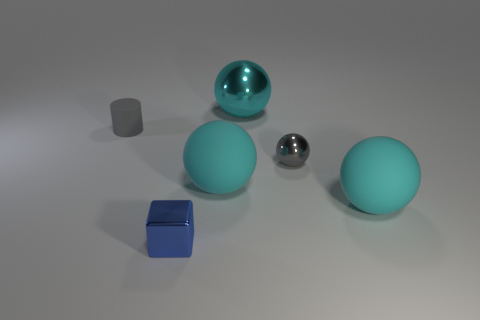What number of yellow objects are either cylinders or big metallic balls?
Ensure brevity in your answer.  0. There is a small gray object that is on the left side of the blue thing; what is it made of?
Offer a very short reply. Rubber. Are there more small matte things than small gray objects?
Provide a succinct answer. No. Does the shiny thing that is right of the cyan metal sphere have the same shape as the large metal thing?
Keep it short and to the point. Yes. What number of spheres are both to the right of the large cyan metallic thing and to the left of the big cyan metal thing?
Give a very brief answer. 0. What number of gray matte things are the same shape as the tiny blue object?
Your response must be concise. 0. The big thing behind the gray thing on the left side of the cyan shiny sphere is what color?
Make the answer very short. Cyan. Does the big cyan shiny thing have the same shape as the tiny gray object that is in front of the gray matte cylinder?
Offer a terse response. Yes. What material is the object in front of the big rubber thing that is to the right of the large sphere left of the cyan shiny thing?
Your answer should be very brief. Metal. Are there any cylinders that have the same size as the block?
Make the answer very short. Yes. 